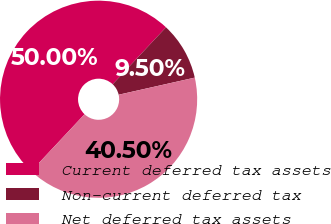<chart> <loc_0><loc_0><loc_500><loc_500><pie_chart><fcel>Current deferred tax assets<fcel>Non-current deferred tax<fcel>Net deferred tax assets<nl><fcel>50.0%<fcel>9.5%<fcel>40.5%<nl></chart> 